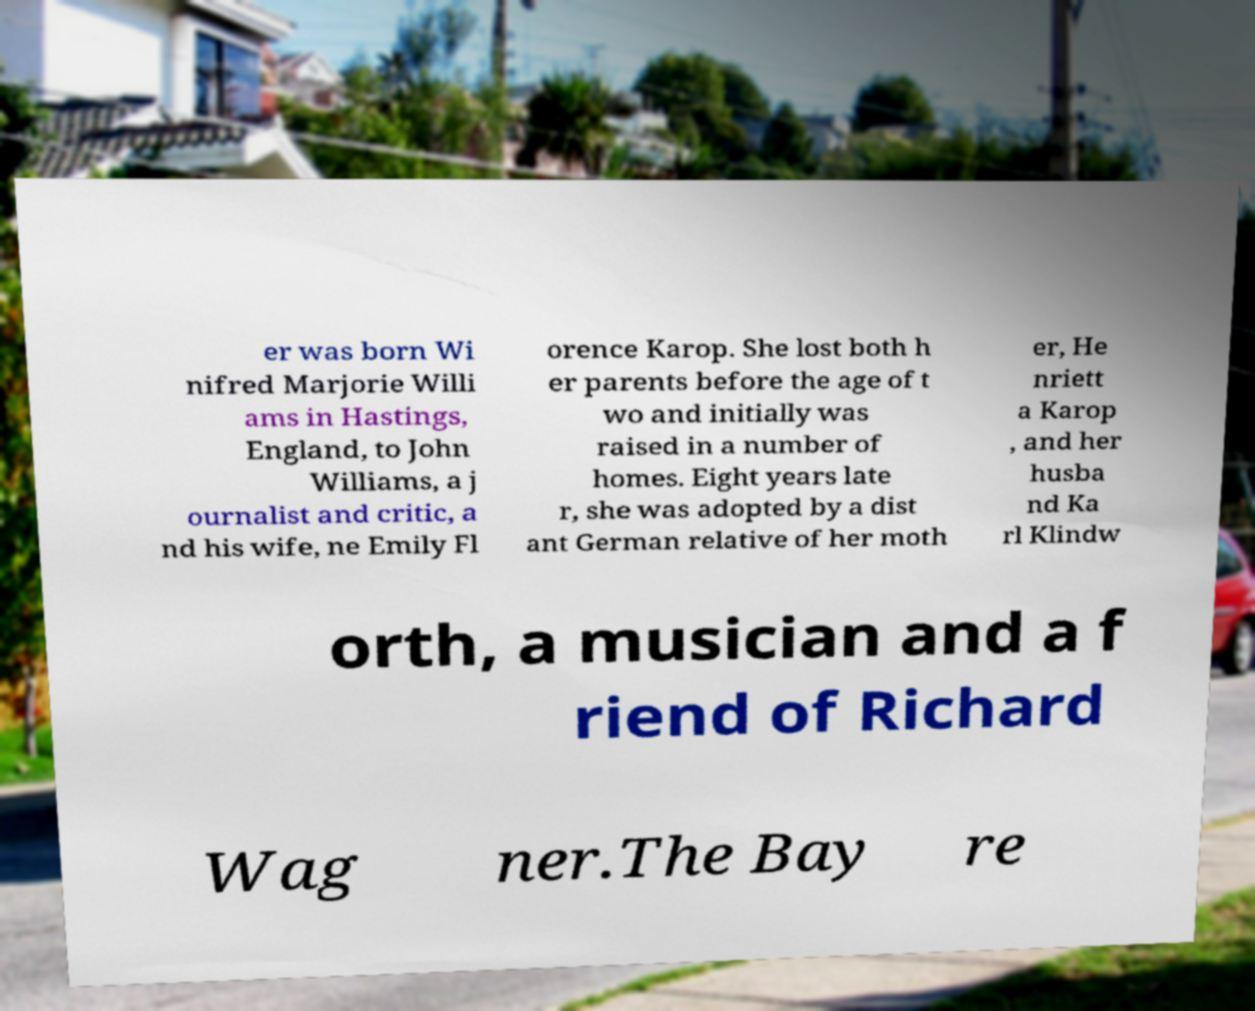There's text embedded in this image that I need extracted. Can you transcribe it verbatim? er was born Wi nifred Marjorie Willi ams in Hastings, England, to John Williams, a j ournalist and critic, a nd his wife, ne Emily Fl orence Karop. She lost both h er parents before the age of t wo and initially was raised in a number of homes. Eight years late r, she was adopted by a dist ant German relative of her moth er, He nriett a Karop , and her husba nd Ka rl Klindw orth, a musician and a f riend of Richard Wag ner.The Bay re 